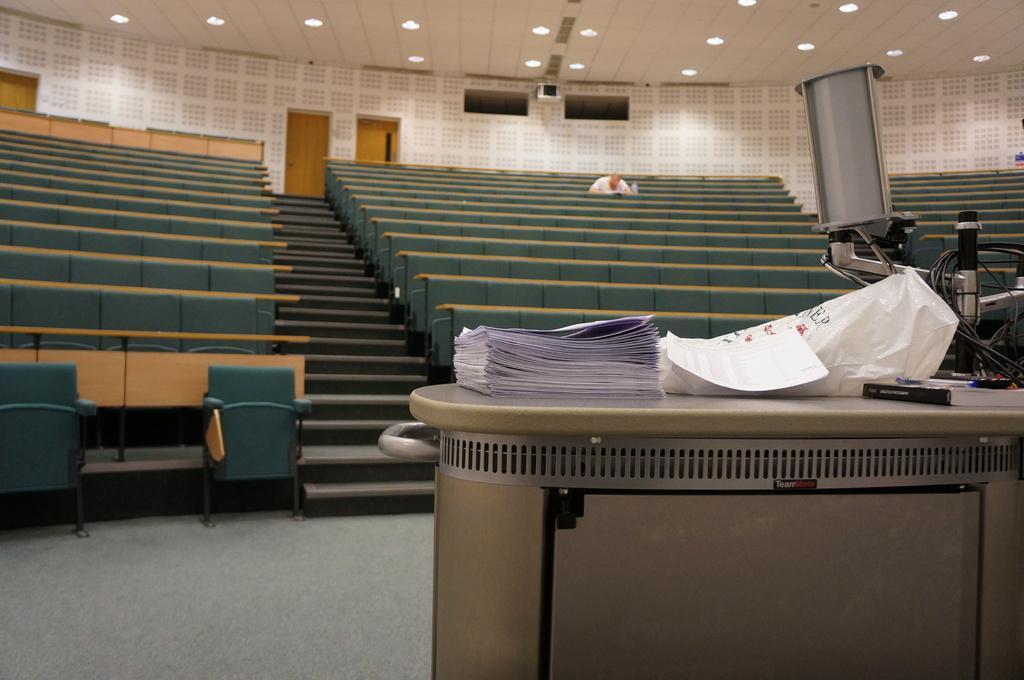Please provide a concise description of this image. In the image in the center, we can see one table. On the table, we can see papers, on plastic cover, box, etc.. In front of the table, we can see one object. In the background there is a wall, doors, lights, chairs, one person sitting and a few other objects. 